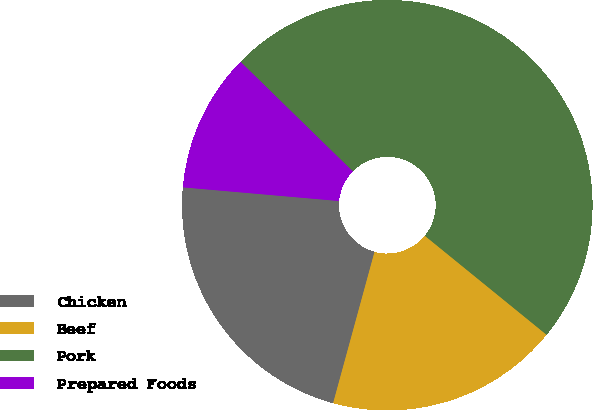Convert chart. <chart><loc_0><loc_0><loc_500><loc_500><pie_chart><fcel>Chicken<fcel>Beef<fcel>Pork<fcel>Prepared Foods<nl><fcel>22.14%<fcel>18.38%<fcel>48.55%<fcel>10.92%<nl></chart> 